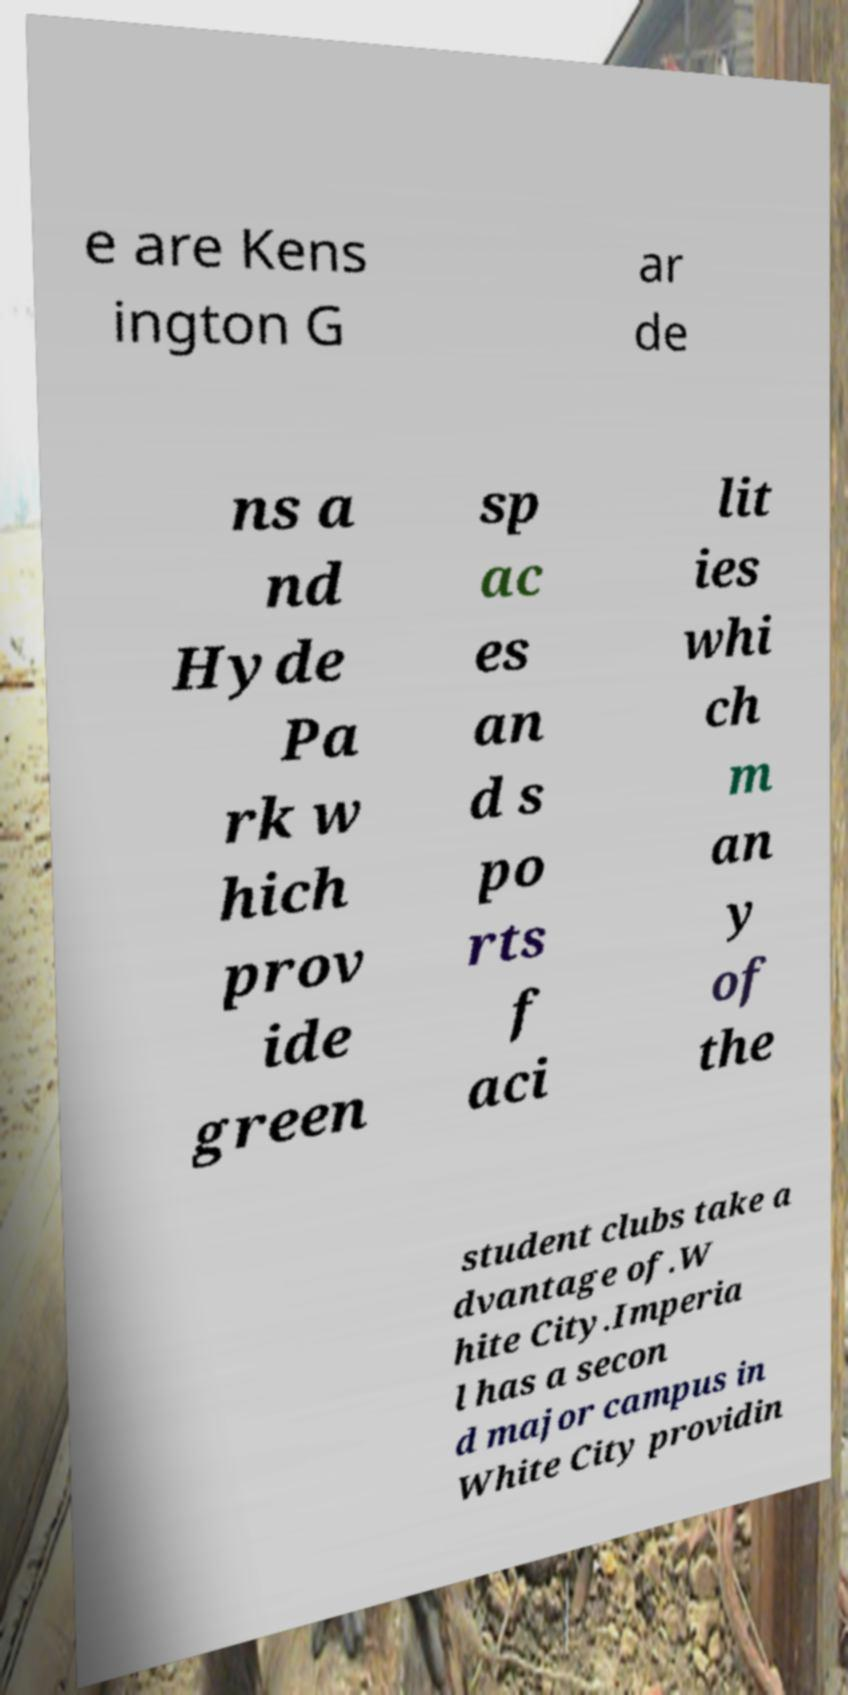Can you accurately transcribe the text from the provided image for me? e are Kens ington G ar de ns a nd Hyde Pa rk w hich prov ide green sp ac es an d s po rts f aci lit ies whi ch m an y of the student clubs take a dvantage of.W hite City.Imperia l has a secon d major campus in White City providin 